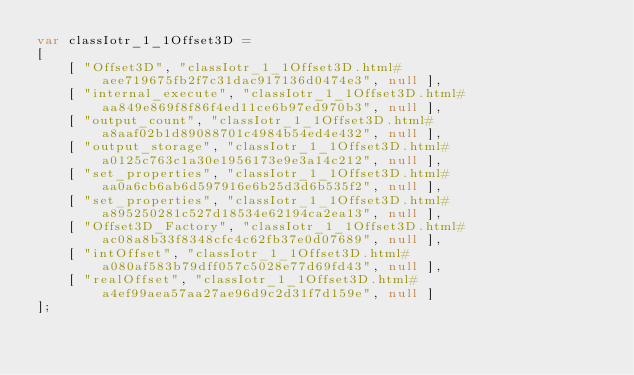Convert code to text. <code><loc_0><loc_0><loc_500><loc_500><_JavaScript_>var classIotr_1_1Offset3D =
[
    [ "Offset3D", "classIotr_1_1Offset3D.html#aee719675fb2f7c31dac917136d0474e3", null ],
    [ "internal_execute", "classIotr_1_1Offset3D.html#aa849e869f8f86f4ed11ce6b97ed970b3", null ],
    [ "output_count", "classIotr_1_1Offset3D.html#a8aaf02b1d89088701c4984b54ed4e432", null ],
    [ "output_storage", "classIotr_1_1Offset3D.html#a0125c763c1a30e1956173e9e3a14c212", null ],
    [ "set_properties", "classIotr_1_1Offset3D.html#aa0a6cb6ab6d597916e6b25d3d6b535f2", null ],
    [ "set_properties", "classIotr_1_1Offset3D.html#a895250281c527d18534e62194ca2ea13", null ],
    [ "Offset3D_Factory", "classIotr_1_1Offset3D.html#ac08a8b33f8348cfc4c62fb37e0d07689", null ],
    [ "intOffset", "classIotr_1_1Offset3D.html#a080af583b79dff057c5028e77d69fd43", null ],
    [ "realOffset", "classIotr_1_1Offset3D.html#a4ef99aea57aa27ae96d9c2d31f7d159e", null ]
];</code> 